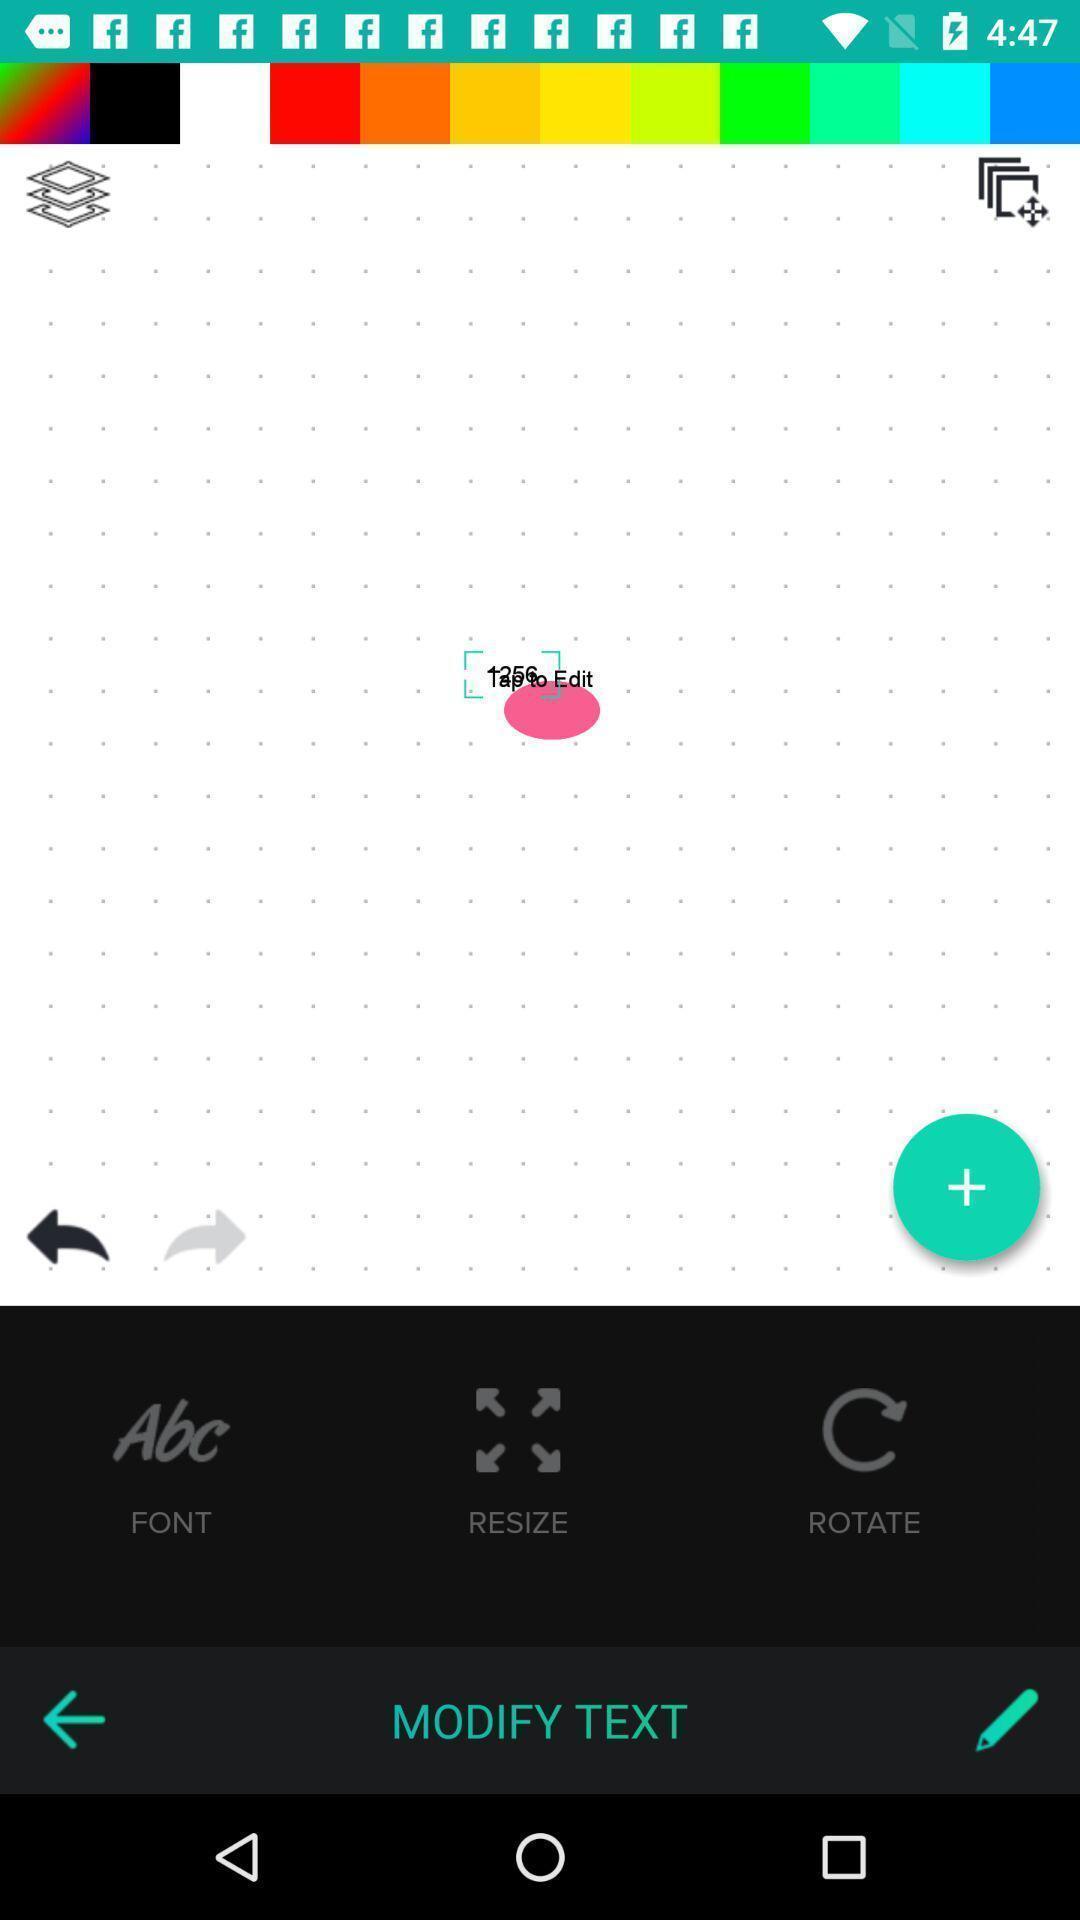Describe this image in words. Screen showing about logo design. 